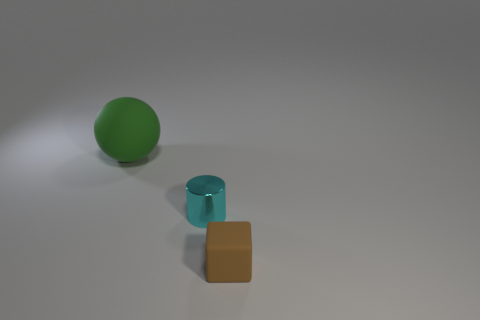What size is the matte object that is behind the rubber block?
Provide a short and direct response. Large. Are there more tiny things in front of the cube than large cubes?
Your answer should be compact. No. The tiny cyan metallic object is what shape?
Provide a short and direct response. Cylinder. There is a object that is left of the cylinder; is it the same color as the tiny cube that is in front of the tiny cyan metal cylinder?
Make the answer very short. No. Do the big rubber object and the brown rubber thing have the same shape?
Your answer should be very brief. No. Is there any other thing that has the same shape as the big thing?
Offer a terse response. No. Is the small thing that is to the left of the tiny brown matte cube made of the same material as the brown cube?
Keep it short and to the point. No. There is a thing that is on the right side of the big green matte object and left of the tiny brown rubber block; what is its shape?
Keep it short and to the point. Cylinder. Are there any things that are on the left side of the rubber object that is behind the brown matte object?
Make the answer very short. No. How many other things are there of the same material as the cylinder?
Give a very brief answer. 0. 